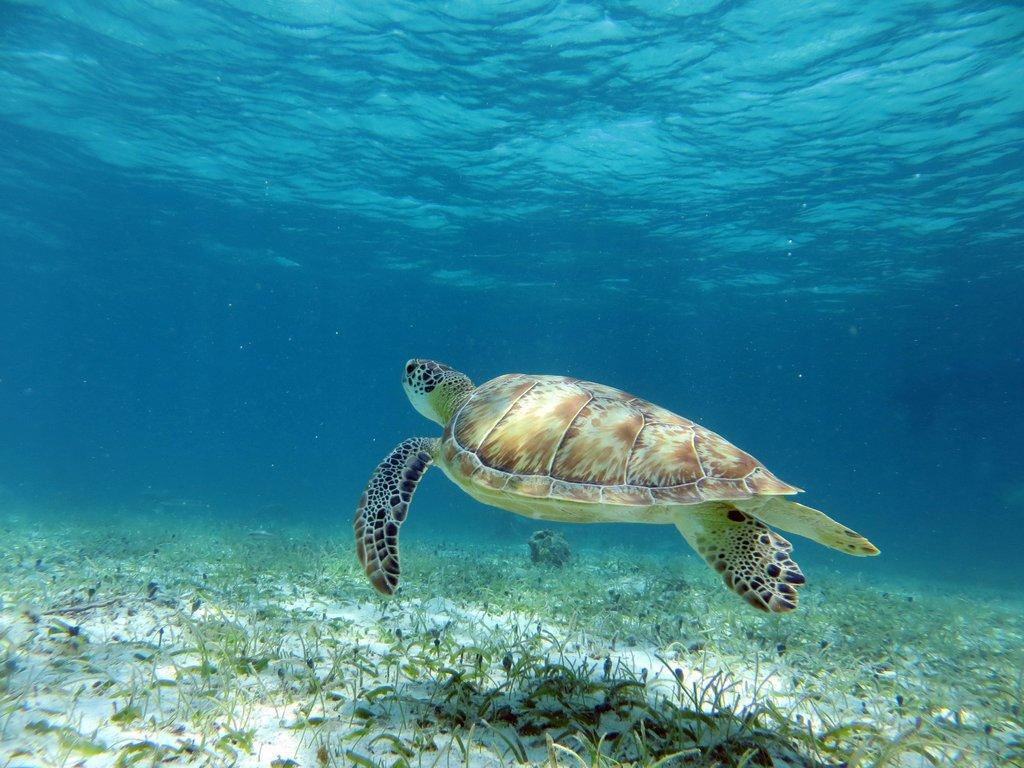What animal is present in the image? There is a tortoise in the image. What colors can be seen on the tortoise? The tortoise has brown, white, and black coloring. Where is the tortoise located in the image? The tortoise is inside the water. What type of vegetation is visible in the image? There is green grass visible in the image. What color is the background of the image? The background of the image is blue. Can you tell me how many deer are present in the image? There are no deer present in the image; it features a tortoise inside the water. Who created the tortoise in the image? The image is a photograph or illustration, not a creation by a person. The tortoise is a living creature in its natural habitat. 